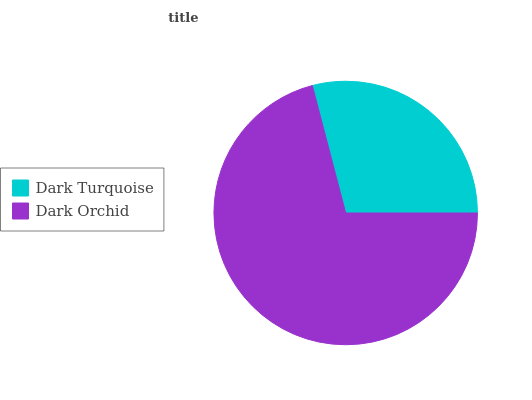Is Dark Turquoise the minimum?
Answer yes or no. Yes. Is Dark Orchid the maximum?
Answer yes or no. Yes. Is Dark Orchid the minimum?
Answer yes or no. No. Is Dark Orchid greater than Dark Turquoise?
Answer yes or no. Yes. Is Dark Turquoise less than Dark Orchid?
Answer yes or no. Yes. Is Dark Turquoise greater than Dark Orchid?
Answer yes or no. No. Is Dark Orchid less than Dark Turquoise?
Answer yes or no. No. Is Dark Orchid the high median?
Answer yes or no. Yes. Is Dark Turquoise the low median?
Answer yes or no. Yes. Is Dark Turquoise the high median?
Answer yes or no. No. Is Dark Orchid the low median?
Answer yes or no. No. 